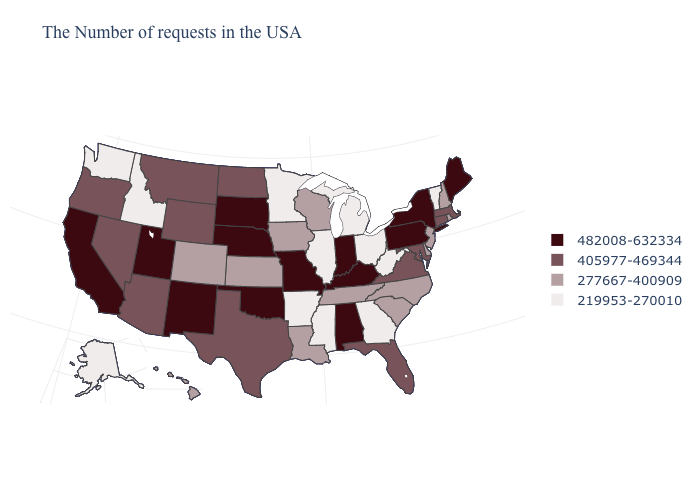Which states have the lowest value in the South?
Give a very brief answer. West Virginia, Georgia, Mississippi, Arkansas. What is the value of Connecticut?
Give a very brief answer. 405977-469344. Name the states that have a value in the range 482008-632334?
Quick response, please. Maine, New York, Pennsylvania, Kentucky, Indiana, Alabama, Missouri, Nebraska, Oklahoma, South Dakota, New Mexico, Utah, California. Does California have the highest value in the West?
Be succinct. Yes. Name the states that have a value in the range 219953-270010?
Keep it brief. Vermont, West Virginia, Ohio, Georgia, Michigan, Illinois, Mississippi, Arkansas, Minnesota, Idaho, Washington, Alaska. Which states hav the highest value in the Northeast?
Write a very short answer. Maine, New York, Pennsylvania. Which states have the lowest value in the USA?
Quick response, please. Vermont, West Virginia, Ohio, Georgia, Michigan, Illinois, Mississippi, Arkansas, Minnesota, Idaho, Washington, Alaska. What is the value of Alabama?
Quick response, please. 482008-632334. What is the lowest value in the USA?
Short answer required. 219953-270010. Does Massachusetts have the same value as Nevada?
Keep it brief. Yes. Which states hav the highest value in the MidWest?
Write a very short answer. Indiana, Missouri, Nebraska, South Dakota. What is the value of New York?
Give a very brief answer. 482008-632334. What is the value of Delaware?
Answer briefly. 277667-400909. What is the value of New Mexico?
Short answer required. 482008-632334. What is the value of Indiana?
Short answer required. 482008-632334. 